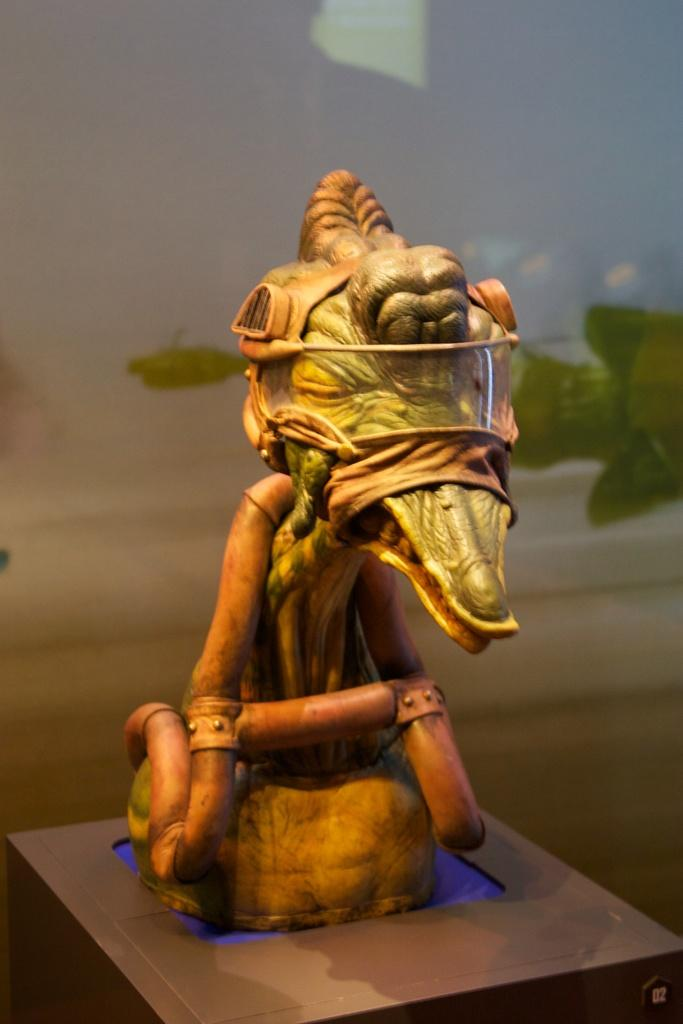What is the main subject of the image? There is a sculpture in the image. What other objects or elements can be seen in the image? There appears to be a plant on the right side of the image, and there is a glass in the background of the image. How many books can be seen in the image? There are no books present in the image. Do the pigs in the image believe in the power of the sculpture? There are no pigs present in the image, so it is not possible to determine their beliefs about the sculpture. 